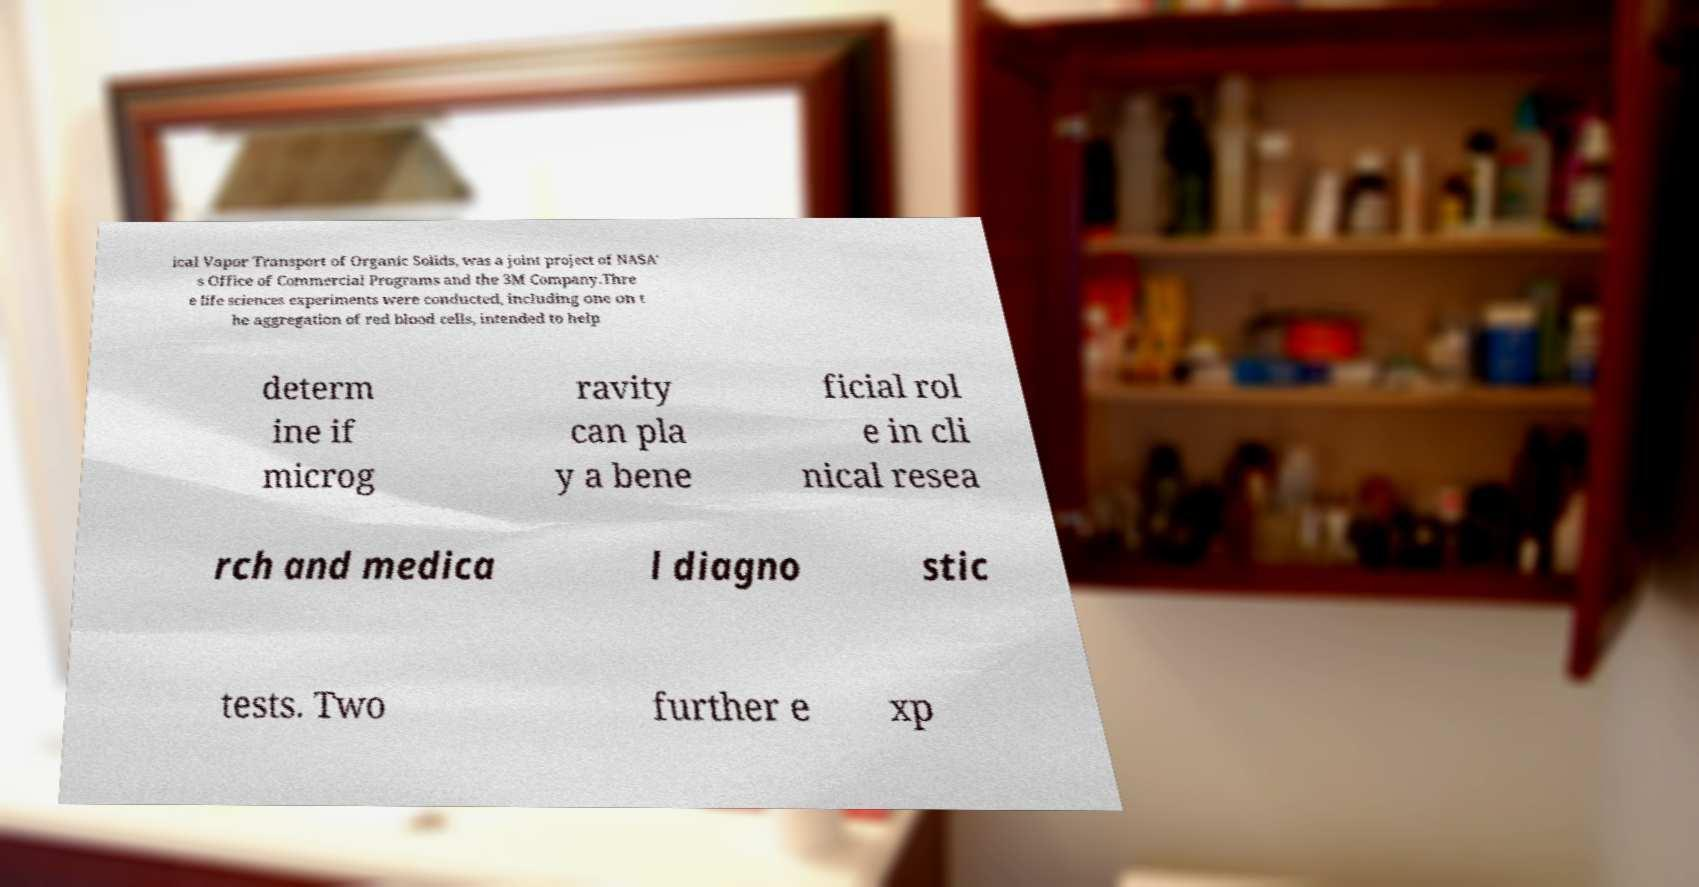There's text embedded in this image that I need extracted. Can you transcribe it verbatim? ical Vapor Transport of Organic Solids, was a joint project of NASA' s Office of Commercial Programs and the 3M Company.Thre e life sciences experiments were conducted, including one on t he aggregation of red blood cells, intended to help determ ine if microg ravity can pla y a bene ficial rol e in cli nical resea rch and medica l diagno stic tests. Two further e xp 